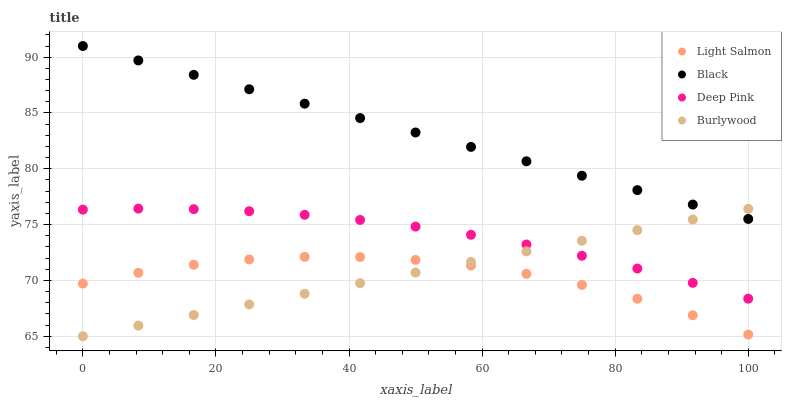Does Light Salmon have the minimum area under the curve?
Answer yes or no. Yes. Does Black have the maximum area under the curve?
Answer yes or no. Yes. Does Deep Pink have the minimum area under the curve?
Answer yes or no. No. Does Deep Pink have the maximum area under the curve?
Answer yes or no. No. Is Burlywood the smoothest?
Answer yes or no. Yes. Is Light Salmon the roughest?
Answer yes or no. Yes. Is Deep Pink the smoothest?
Answer yes or no. No. Is Deep Pink the roughest?
Answer yes or no. No. Does Burlywood have the lowest value?
Answer yes or no. Yes. Does Light Salmon have the lowest value?
Answer yes or no. No. Does Black have the highest value?
Answer yes or no. Yes. Does Deep Pink have the highest value?
Answer yes or no. No. Is Light Salmon less than Deep Pink?
Answer yes or no. Yes. Is Black greater than Deep Pink?
Answer yes or no. Yes. Does Burlywood intersect Black?
Answer yes or no. Yes. Is Burlywood less than Black?
Answer yes or no. No. Is Burlywood greater than Black?
Answer yes or no. No. Does Light Salmon intersect Deep Pink?
Answer yes or no. No. 